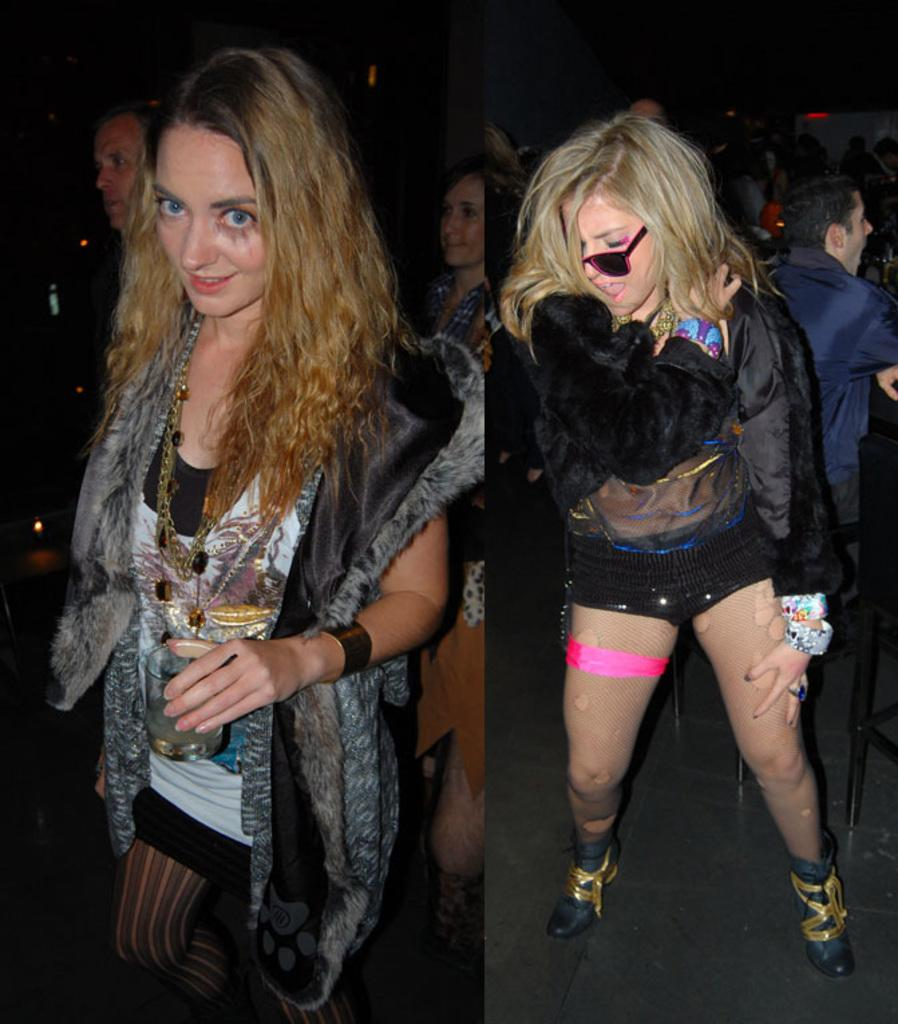What type of artwork is the image? The image is a collage. What can be seen in the collage? There are people standing in the image. What color is the string that the people are holding in the image? There is no string present in the image; it is a collage of people standing. Can you see the veins in the people's arms in the image? The image does not provide enough detail to see the veins in the people's arms. 